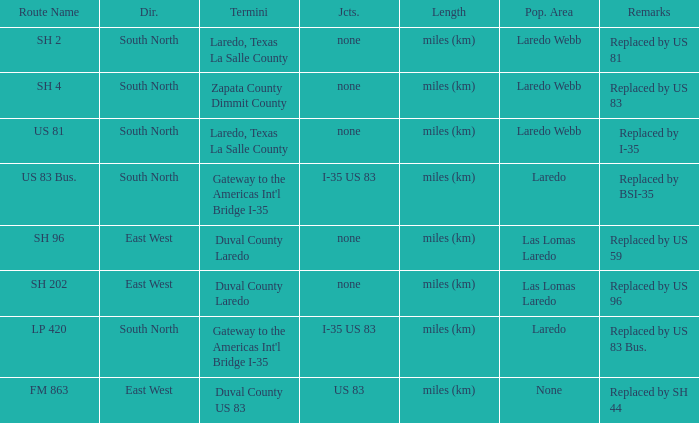Which routes have  "replaced by US 81" listed in their remarks section? SH 2. 